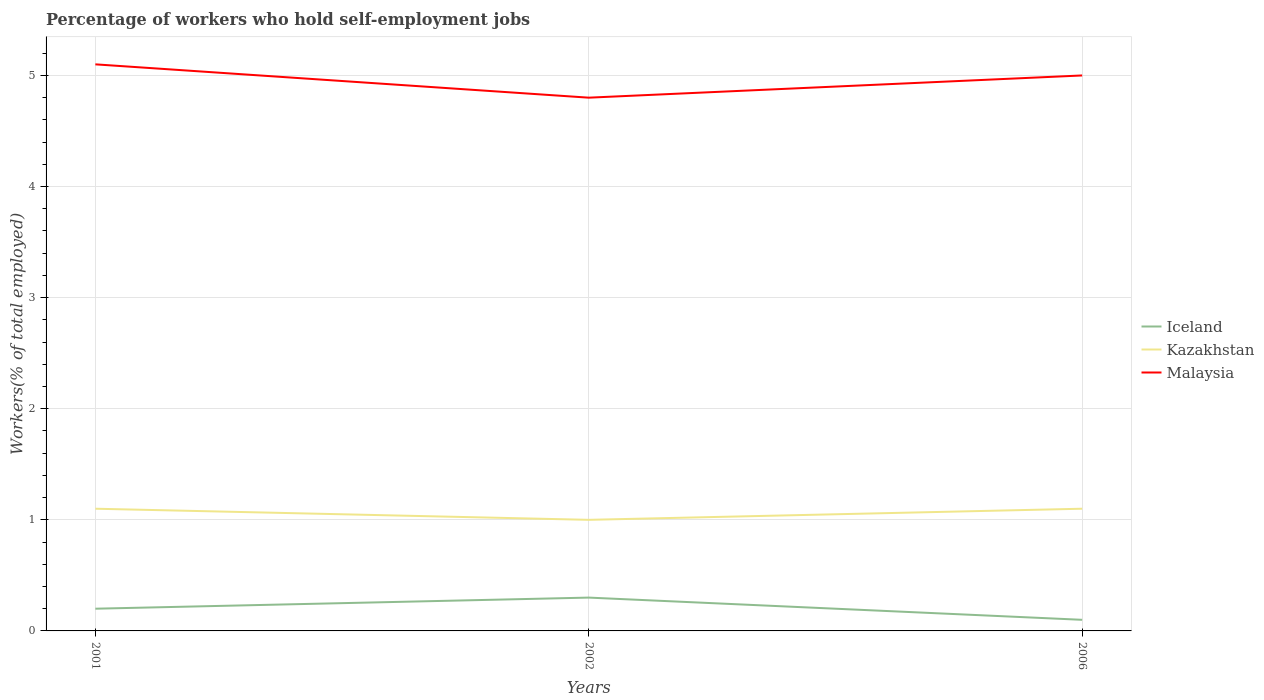How many different coloured lines are there?
Ensure brevity in your answer.  3. Does the line corresponding to Iceland intersect with the line corresponding to Malaysia?
Provide a succinct answer. No. Across all years, what is the maximum percentage of self-employed workers in Kazakhstan?
Your response must be concise. 1. In which year was the percentage of self-employed workers in Iceland maximum?
Your answer should be very brief. 2006. What is the total percentage of self-employed workers in Malaysia in the graph?
Offer a terse response. 0.3. What is the difference between the highest and the second highest percentage of self-employed workers in Malaysia?
Offer a very short reply. 0.3. How many lines are there?
Your answer should be very brief. 3. What is the difference between two consecutive major ticks on the Y-axis?
Provide a succinct answer. 1. Does the graph contain grids?
Provide a succinct answer. Yes. Where does the legend appear in the graph?
Provide a short and direct response. Center right. How many legend labels are there?
Your answer should be compact. 3. How are the legend labels stacked?
Ensure brevity in your answer.  Vertical. What is the title of the graph?
Your answer should be compact. Percentage of workers who hold self-employment jobs. Does "Timor-Leste" appear as one of the legend labels in the graph?
Keep it short and to the point. No. What is the label or title of the Y-axis?
Provide a short and direct response. Workers(% of total employed). What is the Workers(% of total employed) of Iceland in 2001?
Provide a succinct answer. 0.2. What is the Workers(% of total employed) of Kazakhstan in 2001?
Make the answer very short. 1.1. What is the Workers(% of total employed) of Malaysia in 2001?
Your answer should be very brief. 5.1. What is the Workers(% of total employed) in Iceland in 2002?
Provide a succinct answer. 0.3. What is the Workers(% of total employed) in Kazakhstan in 2002?
Give a very brief answer. 1. What is the Workers(% of total employed) in Malaysia in 2002?
Your response must be concise. 4.8. What is the Workers(% of total employed) in Iceland in 2006?
Provide a succinct answer. 0.1. What is the Workers(% of total employed) of Kazakhstan in 2006?
Keep it short and to the point. 1.1. Across all years, what is the maximum Workers(% of total employed) of Iceland?
Make the answer very short. 0.3. Across all years, what is the maximum Workers(% of total employed) in Kazakhstan?
Keep it short and to the point. 1.1. Across all years, what is the maximum Workers(% of total employed) in Malaysia?
Your answer should be very brief. 5.1. Across all years, what is the minimum Workers(% of total employed) of Iceland?
Your answer should be very brief. 0.1. Across all years, what is the minimum Workers(% of total employed) in Kazakhstan?
Keep it short and to the point. 1. Across all years, what is the minimum Workers(% of total employed) in Malaysia?
Provide a succinct answer. 4.8. What is the total Workers(% of total employed) in Malaysia in the graph?
Provide a short and direct response. 14.9. What is the difference between the Workers(% of total employed) in Kazakhstan in 2001 and that in 2002?
Your answer should be very brief. 0.1. What is the difference between the Workers(% of total employed) of Kazakhstan in 2001 and that in 2006?
Provide a short and direct response. 0. What is the difference between the Workers(% of total employed) of Malaysia in 2002 and that in 2006?
Provide a succinct answer. -0.2. What is the difference between the Workers(% of total employed) of Kazakhstan in 2001 and the Workers(% of total employed) of Malaysia in 2002?
Your response must be concise. -3.7. What is the difference between the Workers(% of total employed) in Iceland in 2001 and the Workers(% of total employed) in Kazakhstan in 2006?
Your answer should be very brief. -0.9. What is the difference between the Workers(% of total employed) in Iceland in 2002 and the Workers(% of total employed) in Malaysia in 2006?
Your answer should be very brief. -4.7. What is the average Workers(% of total employed) in Kazakhstan per year?
Keep it short and to the point. 1.07. What is the average Workers(% of total employed) in Malaysia per year?
Your answer should be very brief. 4.97. In the year 2001, what is the difference between the Workers(% of total employed) in Iceland and Workers(% of total employed) in Kazakhstan?
Your answer should be compact. -0.9. In the year 2002, what is the difference between the Workers(% of total employed) of Iceland and Workers(% of total employed) of Kazakhstan?
Your answer should be compact. -0.7. In the year 2002, what is the difference between the Workers(% of total employed) in Kazakhstan and Workers(% of total employed) in Malaysia?
Your response must be concise. -3.8. In the year 2006, what is the difference between the Workers(% of total employed) of Iceland and Workers(% of total employed) of Kazakhstan?
Provide a succinct answer. -1. In the year 2006, what is the difference between the Workers(% of total employed) in Iceland and Workers(% of total employed) in Malaysia?
Keep it short and to the point. -4.9. What is the ratio of the Workers(% of total employed) of Iceland in 2001 to that in 2002?
Keep it short and to the point. 0.67. What is the ratio of the Workers(% of total employed) of Kazakhstan in 2001 to that in 2002?
Provide a succinct answer. 1.1. What is the ratio of the Workers(% of total employed) of Malaysia in 2001 to that in 2002?
Give a very brief answer. 1.06. What is the ratio of the Workers(% of total employed) in Malaysia in 2001 to that in 2006?
Keep it short and to the point. 1.02. What is the ratio of the Workers(% of total employed) of Iceland in 2002 to that in 2006?
Provide a short and direct response. 3. What is the difference between the highest and the second highest Workers(% of total employed) in Iceland?
Keep it short and to the point. 0.1. What is the difference between the highest and the second highest Workers(% of total employed) in Kazakhstan?
Keep it short and to the point. 0. What is the difference between the highest and the second highest Workers(% of total employed) of Malaysia?
Keep it short and to the point. 0.1. What is the difference between the highest and the lowest Workers(% of total employed) of Kazakhstan?
Offer a very short reply. 0.1. 